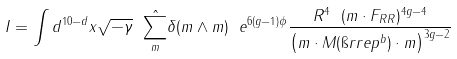<formula> <loc_0><loc_0><loc_500><loc_500>I = \int d ^ { 1 0 - d } x \sqrt { - \gamma } \ \hat { \sum _ { m } } \delta ( m \wedge m ) \ e ^ { 6 ( g - 1 ) \phi } \frac { R ^ { 4 } \ ( m \cdot F _ { R R } ) ^ { 4 g - 4 } } { \left ( m \cdot { M } ( \i r r e p { ^ { b } } ) \cdot m \right ) ^ { 3 g - 2 } }</formula> 